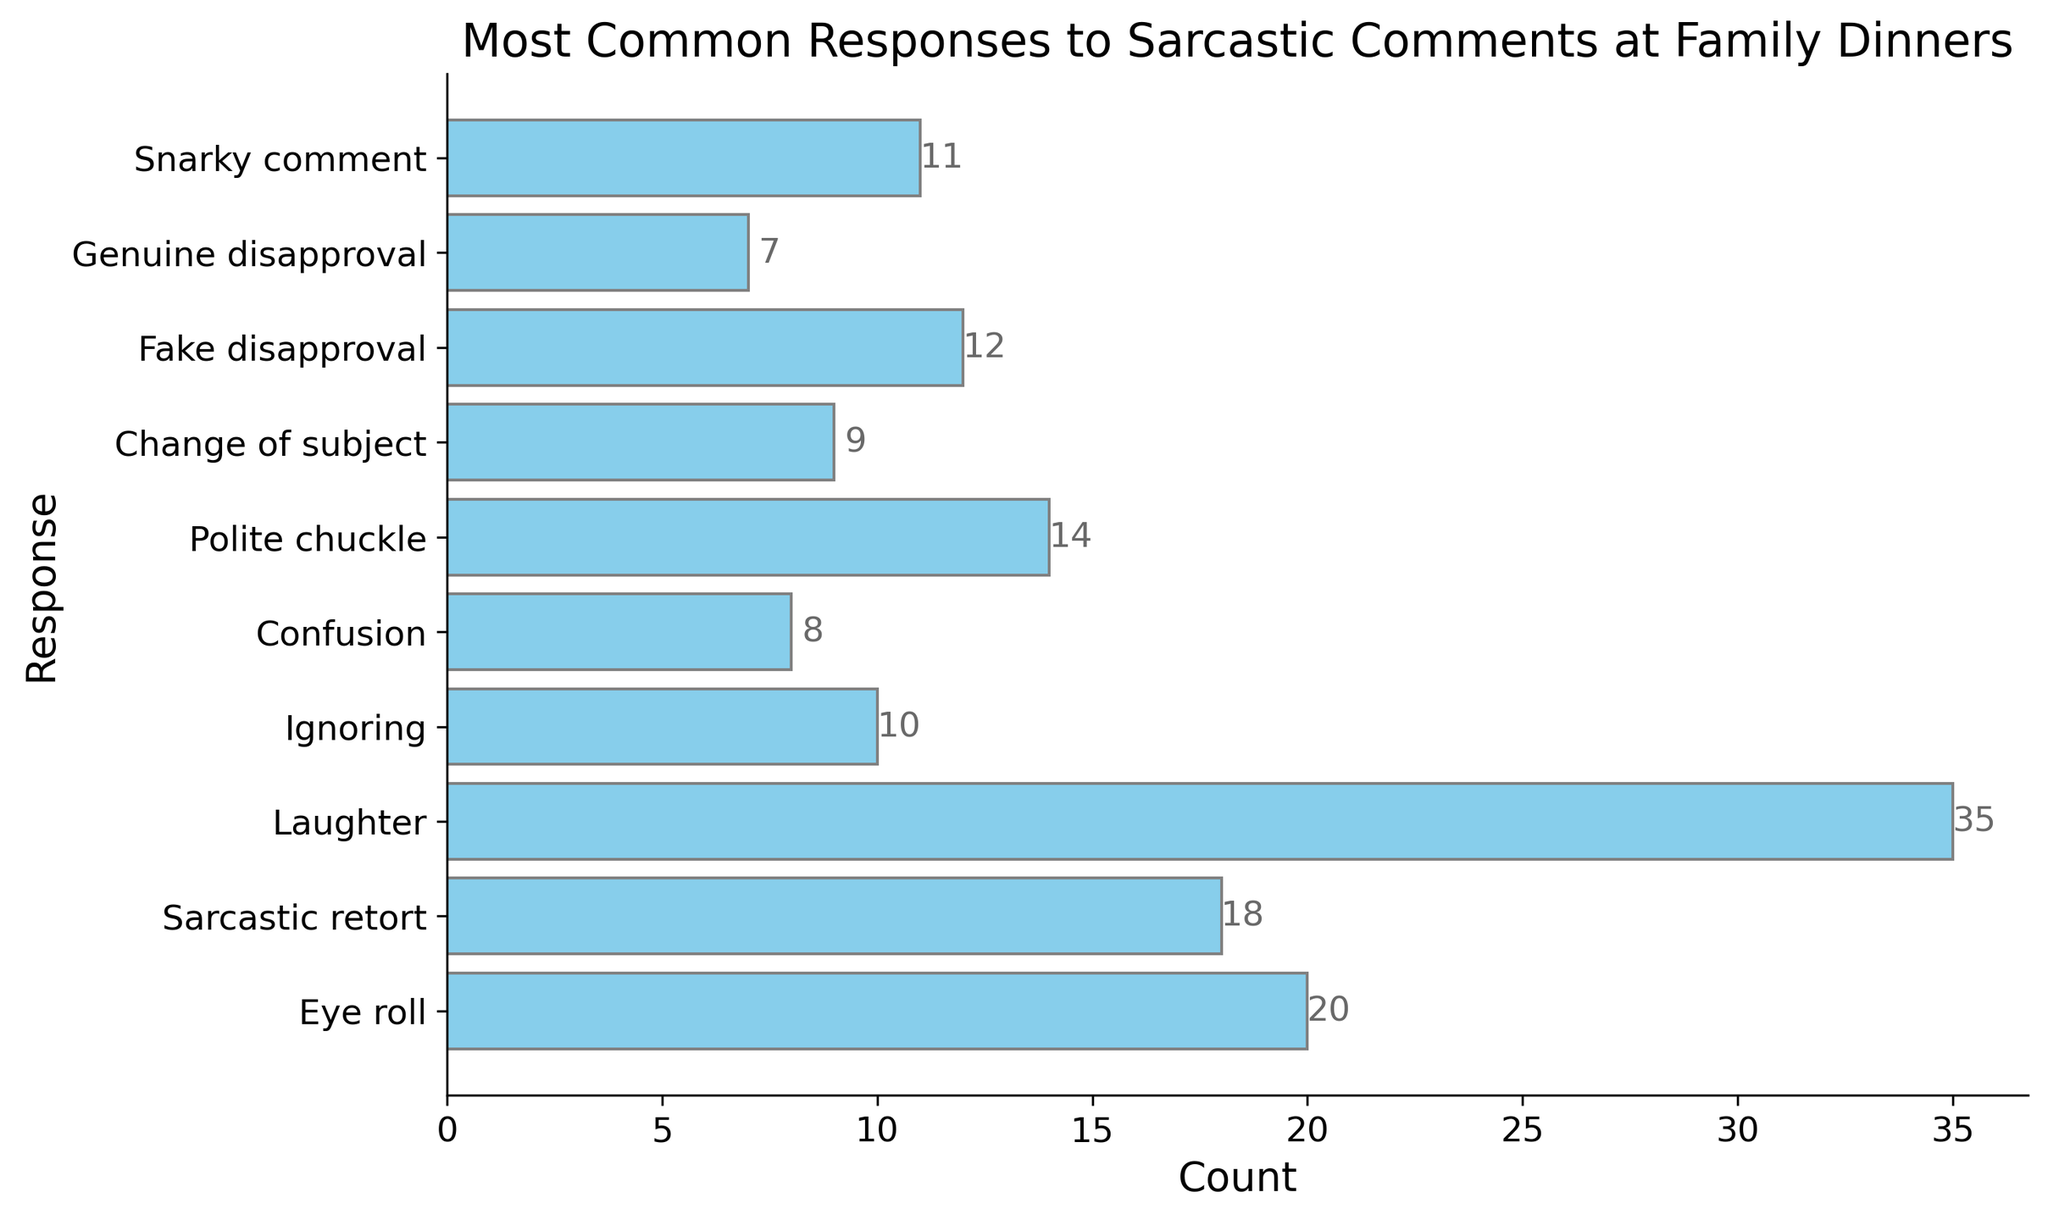How many total responses were recorded in the bar chart? Sum the counts for each response: 20 + 18 + 35 + 10 + 8 + 14 + 9 + 12 + 7 + 11 = 144
Answer: 144 Which response has the highest number of counts? Look at the bar lengths or the labels to see which count is the largest. The longest bar and highest count is for "Laughter" with 35 counts.
Answer: Laughter How many responses have more than 15 counts? Identify the bars where the counts exceed 15. These are "Eye roll" (20), "Sarcastic retort" (18), and "Laughter" (35). So there are 3 responses.
Answer: 3 What is the difference in counts between "Sarcastic retort" and "Snarky comment"? Subtract the count of "Snarky comment" from "Sarcastic retort". 18 - 11 = 7
Answer: 7 Which is more common, "Ignoring" or "Polite chuckle"? Compare the counts directly. "Ignoring" has 10 counts and "Polite chuckle" has 14 counts. "Polite chuckle" is more common.
Answer: Polite chuckle What is the sum of the counts for "Change of subject" and "Fake disapproval"? Add the counts for both responses: 9 + 12 = 21
Answer: 21 How many responses have counts less than 10? Identify the bars where the counts are below 10. These are "Ignoring" (10), "Confusion" (8), "Change of subject" (9), "Fake disapproval" (12), "Genuine disapproval" (7), and "Snarky comment" (11). So there are 3 responses.
Answer: 3 Which response has the least number of counts? Look at the shortest bar or smallest count value. The smallest count is for "Genuine disapproval" with 7.
Answer: Genuine disapproval 